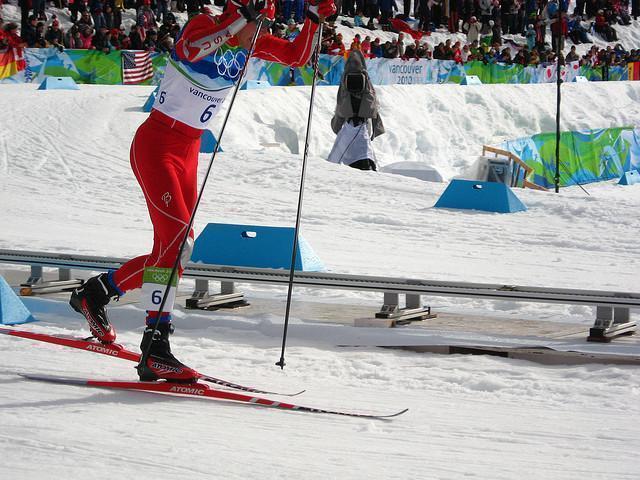What level of event is this?
Choose the right answer from the provided options to respond to the question.
Options: Hobby, national, international, local. International. 